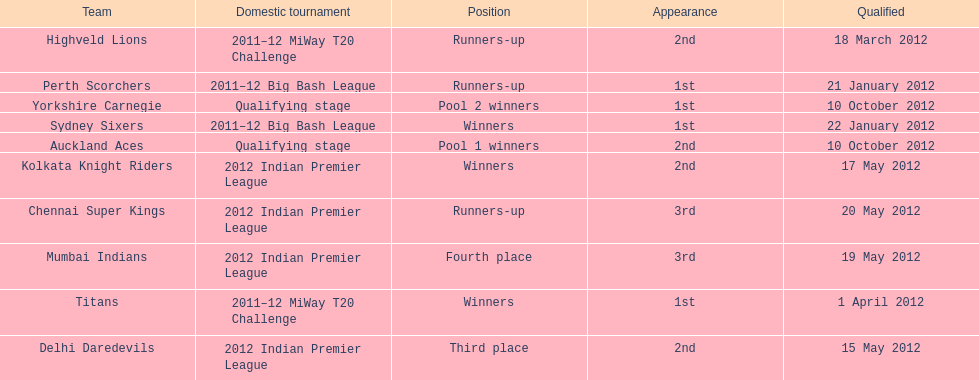Which team made their first appearance in the same tournament as the perth scorchers? Sydney Sixers. 